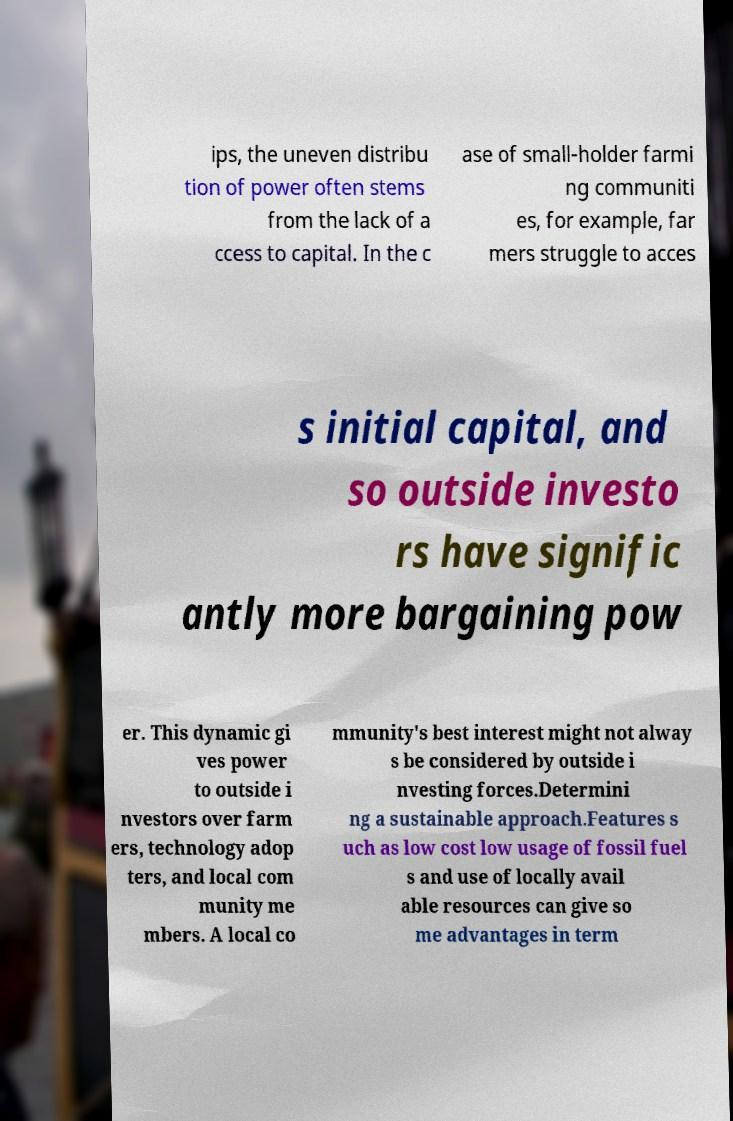Please identify and transcribe the text found in this image. ips, the uneven distribu tion of power often stems from the lack of a ccess to capital. In the c ase of small-holder farmi ng communiti es, for example, far mers struggle to acces s initial capital, and so outside investo rs have signific antly more bargaining pow er. This dynamic gi ves power to outside i nvestors over farm ers, technology adop ters, and local com munity me mbers. A local co mmunity's best interest might not alway s be considered by outside i nvesting forces.Determini ng a sustainable approach.Features s uch as low cost low usage of fossil fuel s and use of locally avail able resources can give so me advantages in term 